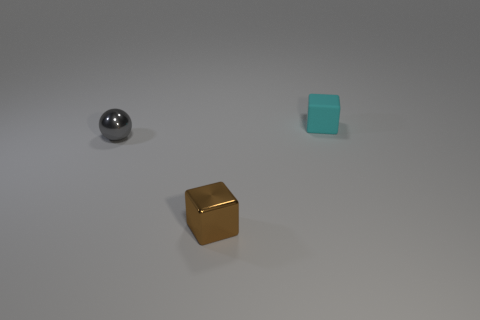There is another thing that is the same shape as the tiny cyan thing; what color is it?
Provide a short and direct response. Brown. Is the number of brown shiny blocks on the right side of the small metallic sphere greater than the number of red metal cylinders?
Your answer should be very brief. Yes. Is the shape of the brown metal object the same as the small thing that is to the left of the tiny brown metal thing?
Offer a terse response. No. Is the number of gray metal objects greater than the number of things?
Give a very brief answer. No. Does the rubber thing have the same shape as the tiny brown shiny object?
Your answer should be compact. Yes. There is a tiny block on the right side of the small cube that is in front of the small cyan matte block; what is it made of?
Keep it short and to the point. Rubber. There is a small cube behind the tiny metallic cube; is there a cube to the left of it?
Keep it short and to the point. Yes. There is a metal thing that is in front of the small gray object; what shape is it?
Offer a very short reply. Cube. What number of cyan cubes are behind the cube that is in front of the tiny thing on the right side of the small brown cube?
Offer a very short reply. 1. There is a cyan matte object; is it the same size as the cube to the left of the small cyan matte object?
Offer a terse response. Yes. 